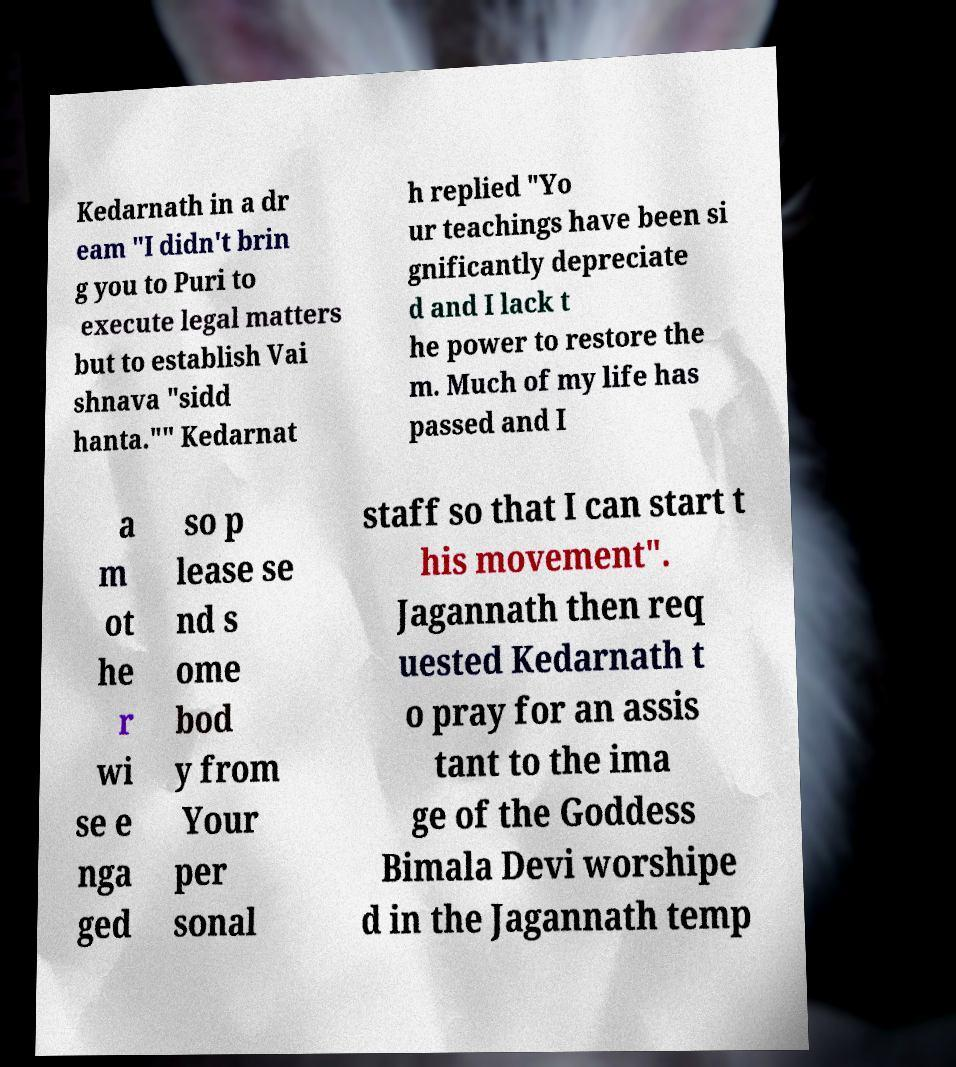Could you assist in decoding the text presented in this image and type it out clearly? Kedarnath in a dr eam "I didn't brin g you to Puri to execute legal matters but to establish Vai shnava "sidd hanta."" Kedarnat h replied "Yo ur teachings have been si gnificantly depreciate d and I lack t he power to restore the m. Much of my life has passed and I a m ot he r wi se e nga ged so p lease se nd s ome bod y from Your per sonal staff so that I can start t his movement". Jagannath then req uested Kedarnath t o pray for an assis tant to the ima ge of the Goddess Bimala Devi worshipe d in the Jagannath temp 